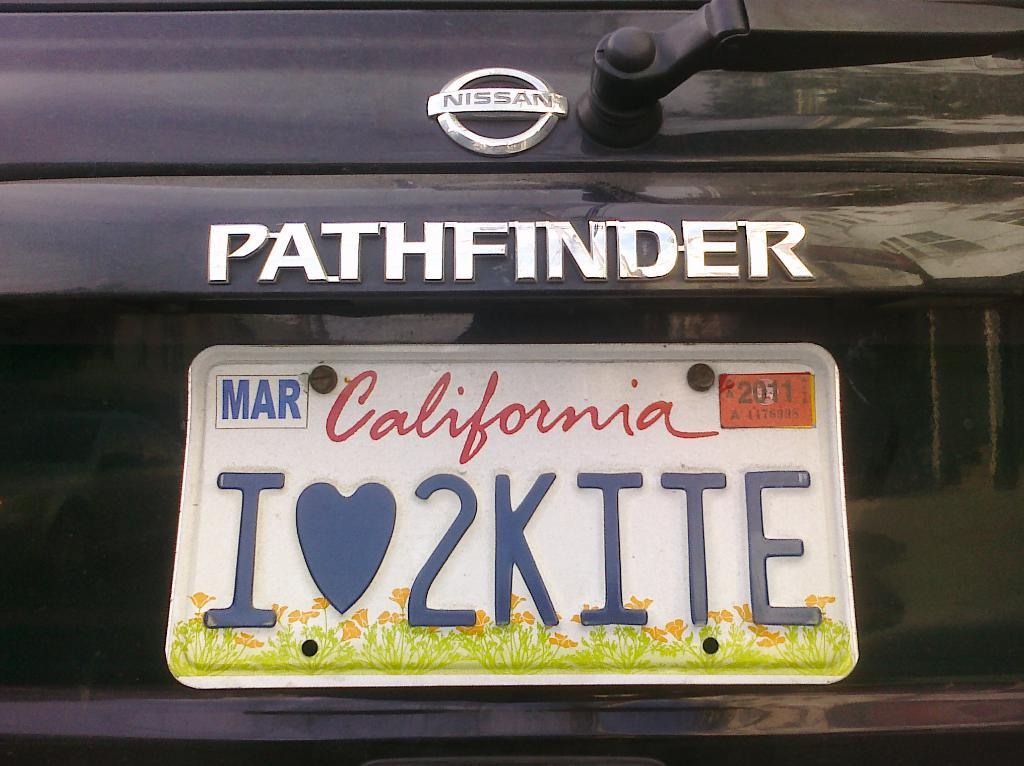<image>
Give a short and clear explanation of the subsequent image. The back bumper of a Nissan Pathfinder with a California state license plate on it. 